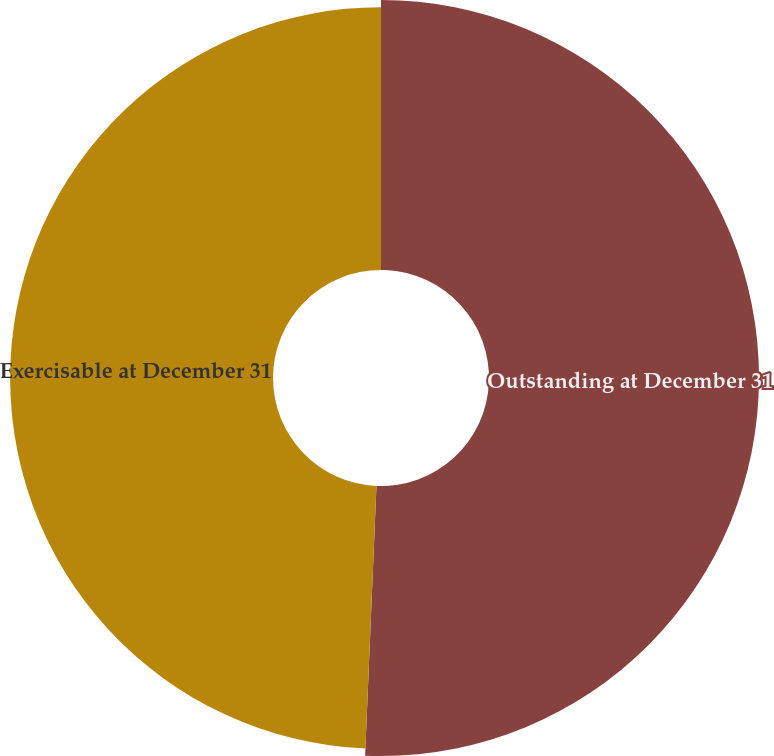Convert chart to OTSL. <chart><loc_0><loc_0><loc_500><loc_500><pie_chart><fcel>Outstanding at December 31<fcel>Exercisable at December 31<nl><fcel>50.67%<fcel>49.33%<nl></chart> 